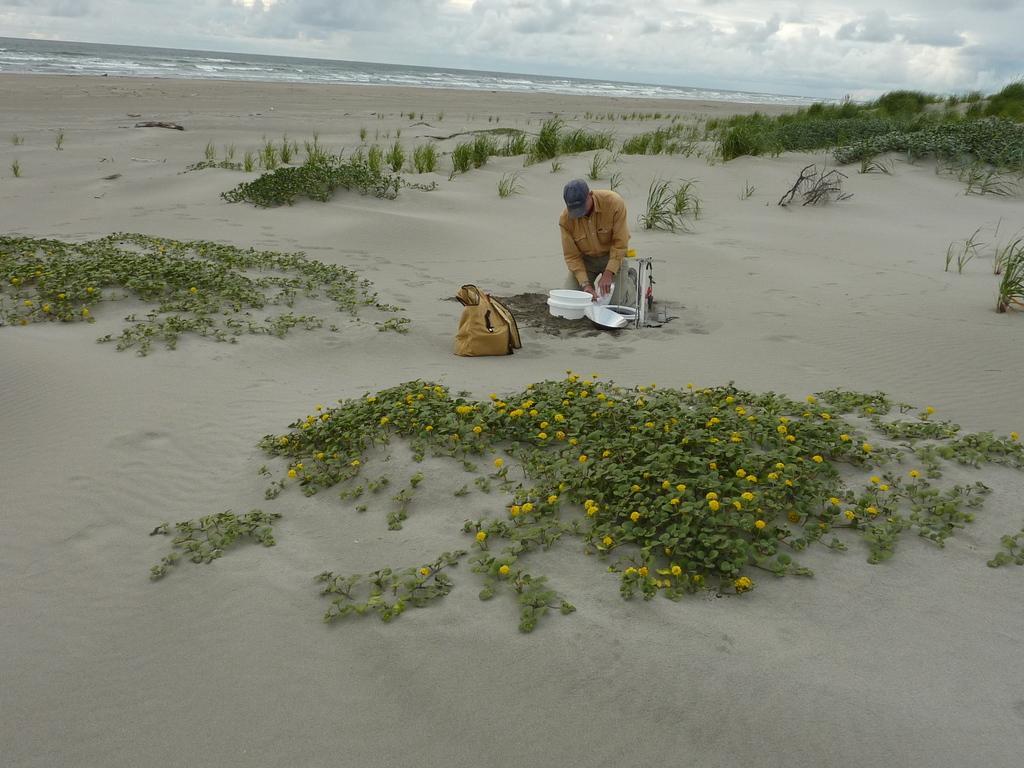Describe this image in one or two sentences. In this image we can see there is a person sitting on the sand and holding a bucket and there is a plate. And there are plants with flowers and there is a water and the cloudy sky. 